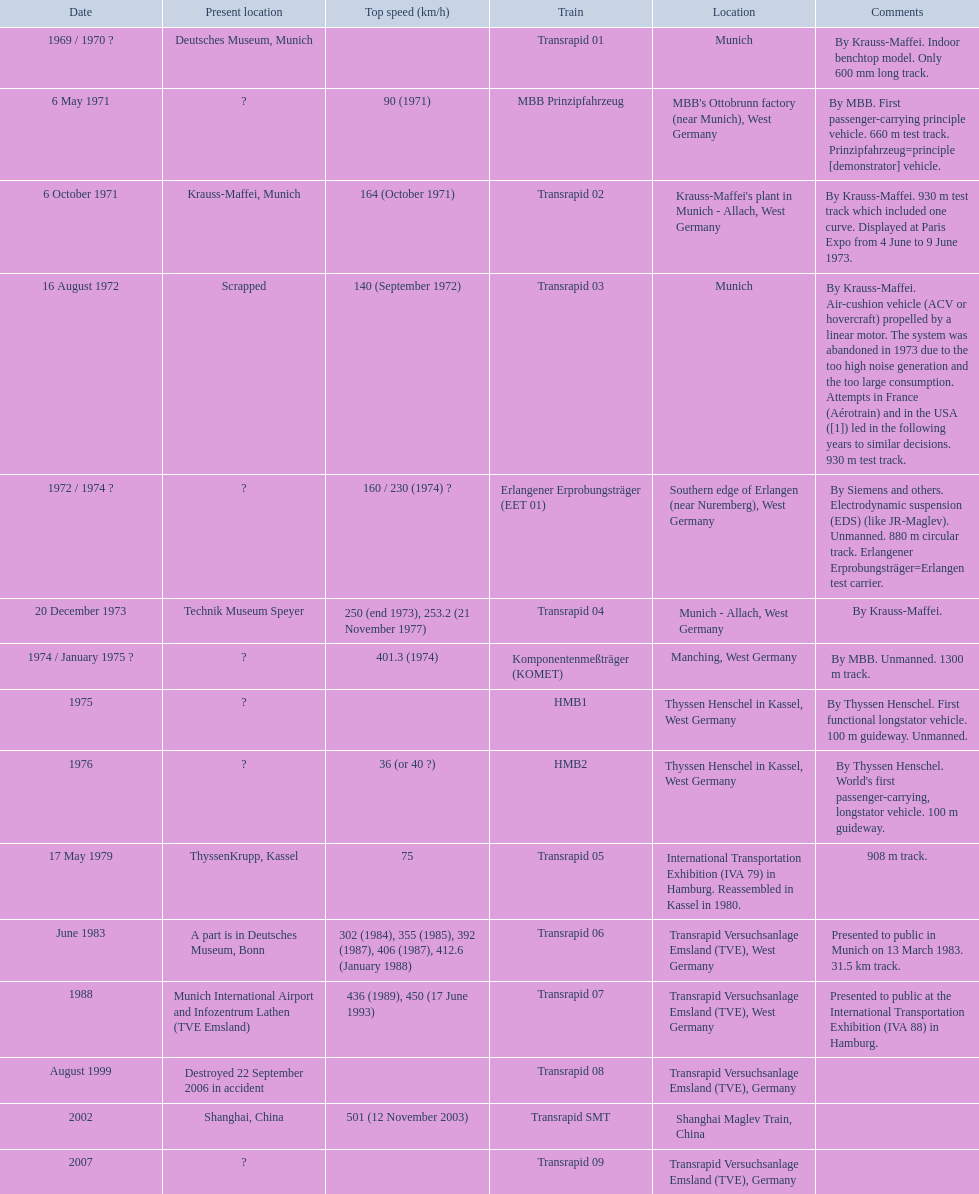What are all of the transrapid trains? Transrapid 01, Transrapid 02, Transrapid 03, Transrapid 04, Transrapid 05, Transrapid 06, Transrapid 07, Transrapid 08, Transrapid SMT, Transrapid 09. Of those, which train had to be scrapped? Transrapid 03. 